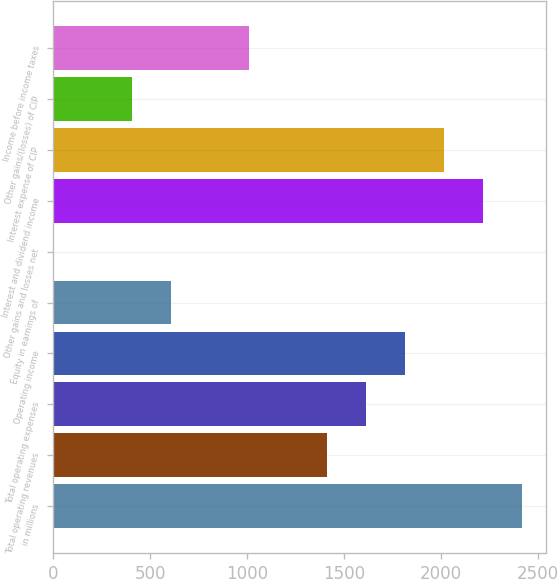Convert chart. <chart><loc_0><loc_0><loc_500><loc_500><bar_chart><fcel>in millions<fcel>Total operating revenues<fcel>Total operating expenses<fcel>Operating income<fcel>Equity in earnings of<fcel>Other gains and losses net<fcel>Interest and dividend income<fcel>Interest expense of CIP<fcel>Other gains/(losses) of CIP<fcel>Income before income taxes<nl><fcel>2418.82<fcel>1411.77<fcel>1613.18<fcel>1814.59<fcel>606.13<fcel>1.9<fcel>2217.41<fcel>2016<fcel>404.72<fcel>1008.95<nl></chart> 